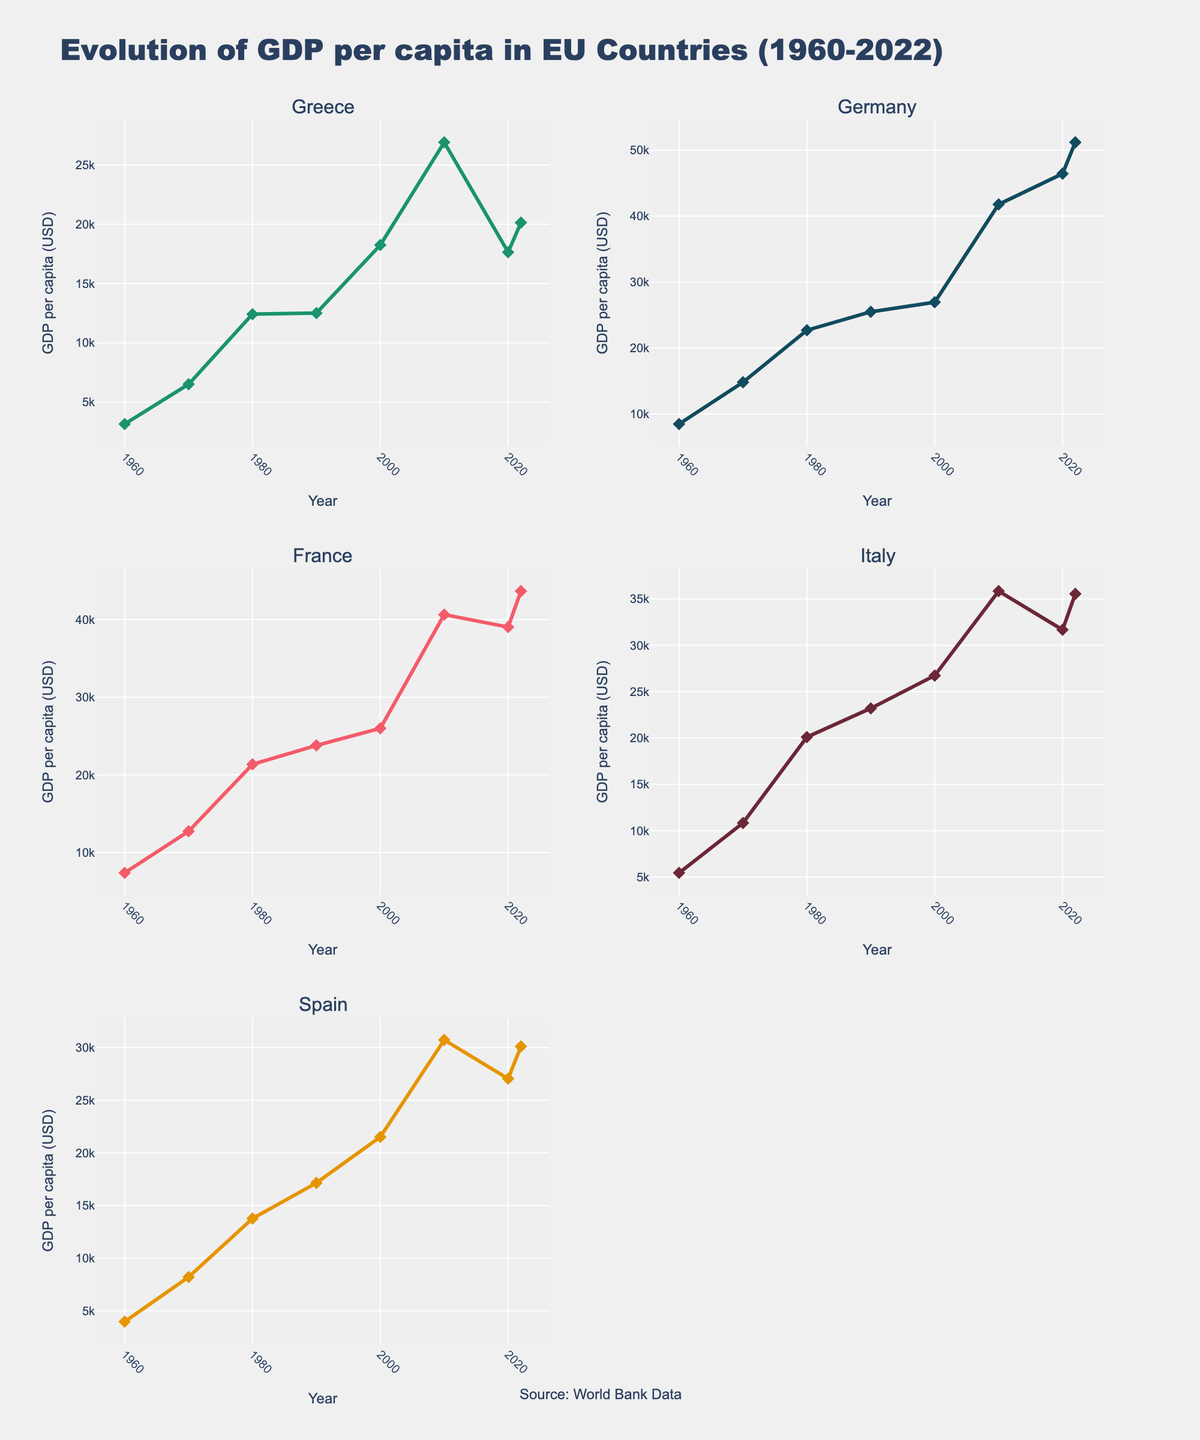what is the title of the figure? The title of the figure is found at the top and is clearly outlined and bolded. It reads, "Evolution of GDP per capita in EU Countries (1960-2022)".
Answer: Evolution of GDP per capita in EU Countries (1960-2022) Which country had the highest GDP per capita in 1960? To find the country with the highest GDP per capita in 1960, look at the starting points of each line. Germany's line starts the highest.
Answer: Germany By how much did Greece's GDP per capita change between 1960 and 2022? Greece's GDP per capita in 1960 was 3146 and in 2022 was 20140. Subtract the 1960 figure from the 2022 figure: 20140 - 3146 = 16994.
Answer: 16994 Which EU country's GDP per capita had the smallest change between 2010 and 2020? Comparing the Y-values for each country at 2010 and 2020, we see that Greece had the smallest change: 26917 in 2010 and 17647 in 2020.
Answer: Greece What is the trend of Greece's GDP per capita from 2010 to 2022? By examining the portion of Greece's line between 2010 and 2022, we observe an initial decline from 2010 to 2020, followed by an increase from 2020 to 2022.
Answer: Initial decline, then increase Did all the countries experience an increase in their GDP per capita from 1960 to 2022? Reviewing the overall trend for each country's line from the leftmost (1960) to the rightmost point (2022), all lines show an upward trend indicating an increase.
Answer: Yes How did Spain's GDP per capita in 2022 compare with that of Italy in the same year? By comparing the values at 2022 for Spain (30115) and Italy (35551), Italy’s GDP per capita is higher.
Answer: Italy's GDP per capita is higher What's the average GDP per capita of France in the 2020s data points provided? France's GDP per capita values for the 2020s are 39030 (2020) and 43659 (2022). Summing these and dividing by 2 gives (39030 + 43659) / 2 = 41344.5.
Answer: 41344.5 Which country shows the steepest increase in GDP per capita from 1960 to 2022? The country with the steepest increase has the most pronounced upward slope when moving from 1960 to 2022. Germany shows the steepest increase.
Answer: Germany How did GDP per capita trends change for Germany post-2010 compared to previous decades? Examining Germany's line, the slope post-2010 is less steep compared to previous periods showing stabilization, especially between 2010 and 2022.
Answer: Less steep, stabilization 